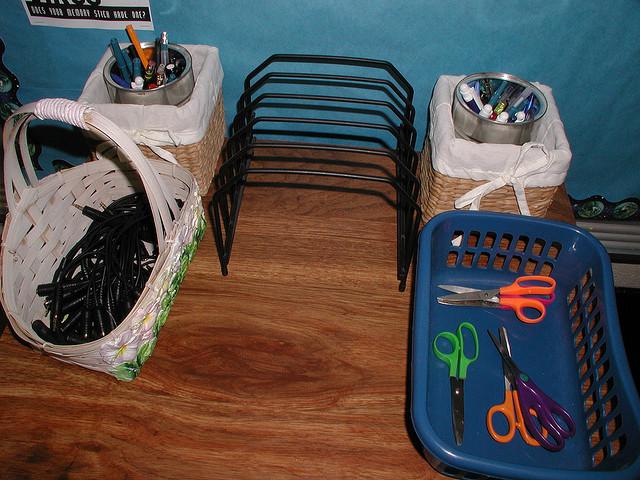How many pairs of scissors are pictured?
Answer briefly. 4. How many baskets are pictured?
Write a very short answer. 4. What color are the baskets?
Keep it brief. Blue and white. 